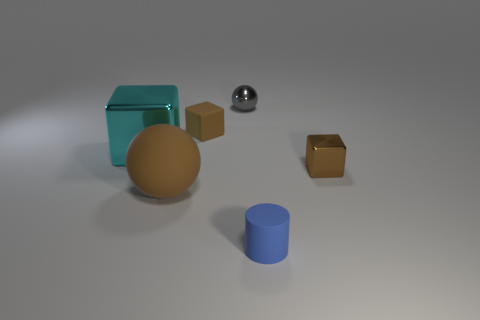There is a tiny object that is to the left of the small gray ball; what number of matte objects are to the right of it?
Your answer should be compact. 1. There is a gray metallic thing; what shape is it?
Your answer should be very brief. Sphere. The big thing that is made of the same material as the small blue cylinder is what shape?
Provide a succinct answer. Sphere. There is a brown thing to the right of the tiny blue rubber cylinder; is it the same shape as the blue rubber object?
Your answer should be compact. No. What shape is the tiny rubber object that is in front of the brown ball?
Offer a terse response. Cylinder. What shape is the big rubber object that is the same color as the tiny rubber block?
Your answer should be very brief. Sphere. What number of gray shiny spheres have the same size as the blue matte object?
Your response must be concise. 1. The small ball has what color?
Keep it short and to the point. Gray. Does the tiny shiny ball have the same color as the shiny block on the left side of the tiny cylinder?
Your response must be concise. No. What size is the brown thing that is the same material as the small ball?
Provide a short and direct response. Small. 